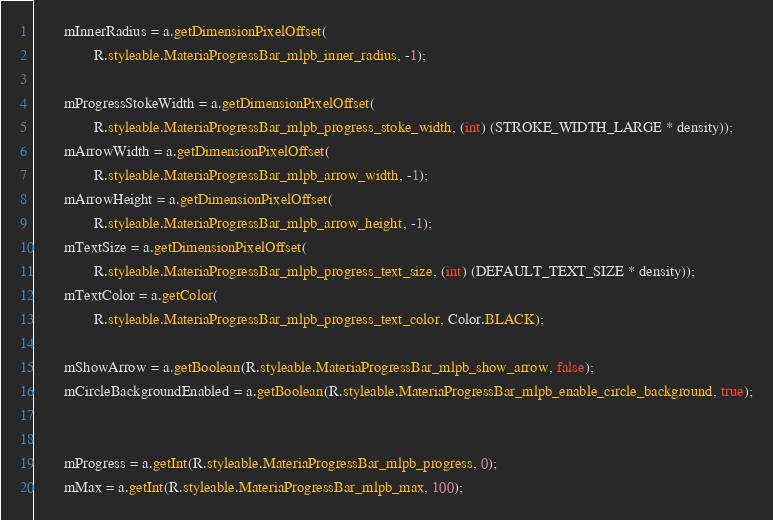<code> <loc_0><loc_0><loc_500><loc_500><_Java_>
        mInnerRadius = a.getDimensionPixelOffset(
                R.styleable.MateriaProgressBar_mlpb_inner_radius, -1);

        mProgressStokeWidth = a.getDimensionPixelOffset(
                R.styleable.MateriaProgressBar_mlpb_progress_stoke_width, (int) (STROKE_WIDTH_LARGE * density));
        mArrowWidth = a.getDimensionPixelOffset(
                R.styleable.MateriaProgressBar_mlpb_arrow_width, -1);
        mArrowHeight = a.getDimensionPixelOffset(
                R.styleable.MateriaProgressBar_mlpb_arrow_height, -1);
        mTextSize = a.getDimensionPixelOffset(
                R.styleable.MateriaProgressBar_mlpb_progress_text_size, (int) (DEFAULT_TEXT_SIZE * density));
        mTextColor = a.getColor(
                R.styleable.MateriaProgressBar_mlpb_progress_text_color, Color.BLACK);

        mShowArrow = a.getBoolean(R.styleable.MateriaProgressBar_mlpb_show_arrow, false);
        mCircleBackgroundEnabled = a.getBoolean(R.styleable.MateriaProgressBar_mlpb_enable_circle_background, true);


        mProgress = a.getInt(R.styleable.MateriaProgressBar_mlpb_progress, 0);
        mMax = a.getInt(R.styleable.MateriaProgressBar_mlpb_max, 100);</code> 